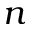<formula> <loc_0><loc_0><loc_500><loc_500>n</formula> 